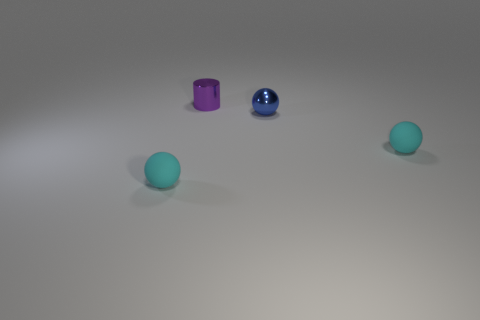What is the shape of the tiny cyan thing left of the cylinder?
Provide a short and direct response. Sphere. How many other small objects are the same shape as the blue shiny thing?
Keep it short and to the point. 2. Is the number of blue objects behind the blue metal object the same as the number of metallic things behind the purple thing?
Your answer should be compact. Yes. Is there another large cyan cylinder made of the same material as the cylinder?
Provide a short and direct response. No. Is the material of the blue sphere the same as the small cylinder?
Your answer should be very brief. Yes. What number of green things are either cylinders or metal objects?
Provide a short and direct response. 0. Is the number of small cyan spheres that are on the left side of the tiny metal ball greater than the number of big brown matte objects?
Your answer should be very brief. Yes. Are there any other tiny metallic spheres that have the same color as the tiny metal sphere?
Give a very brief answer. No. The purple cylinder is what size?
Ensure brevity in your answer.  Small. Do the cylinder and the small shiny ball have the same color?
Offer a very short reply. No. 